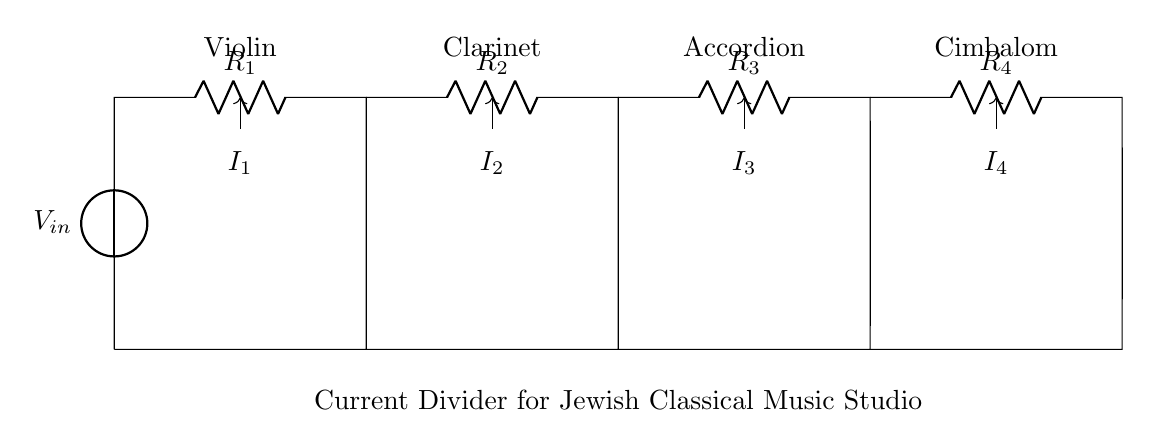What is the input voltage of this circuit? The input voltage is marked as V_in, which represents the voltage supplied to the circuit. This voltage is commonly provided by a power source.
Answer: V_in What type of circuit is shown in the diagram? The circuit is a current divider, which is designed to split the input current into multiple branches to distribute to different components connected in parallel.
Answer: Current divider How many resistors are present in this current divider? There are four resistors labeled R1, R2, R3, and R4 in the circuit, which collectively divide the current among the electric instruments.
Answer: Four Which instrument receives the second current? The second current is labeled I2, which flows to the clarinet as indicated by its label above the branch.
Answer: Clarinet If the total input current is 10A, how much current goes to R3? To find the current through R3, you would apply the current divider formula. The specific value would depend on the resistor values. Since no values are provided, let's assume R3 splits a portion based on its resistance compared to others.
Answer: Depends on resistances What happens to the total current when the resistance of R4 increases? Increasing R4 will result in a decrease in the current flowing through R4 according to Ohm's law, while the other currents may also be affected depending on the new total resistance. This is because current in parallel circuits inversely relates to resistance.
Answer: Decrease overall Which instrument has the least resistance based on the circuit? The instrument with the least resistance would be identified by looking at the resistors chosen for each branch. However, since values are not given, we cannot determine which instrument directly from this diagram.
Answer: Not determinable 